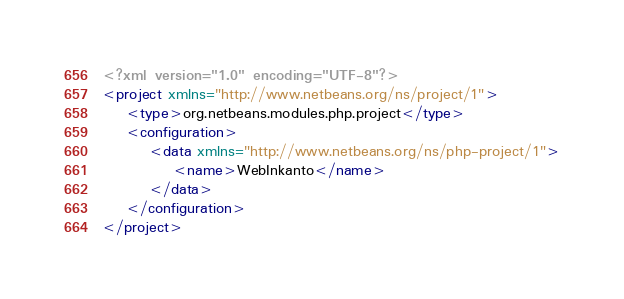<code> <loc_0><loc_0><loc_500><loc_500><_XML_><?xml version="1.0" encoding="UTF-8"?>
<project xmlns="http://www.netbeans.org/ns/project/1">
    <type>org.netbeans.modules.php.project</type>
    <configuration>
        <data xmlns="http://www.netbeans.org/ns/php-project/1">
            <name>WebInkanto</name>
        </data>
    </configuration>
</project>
</code> 